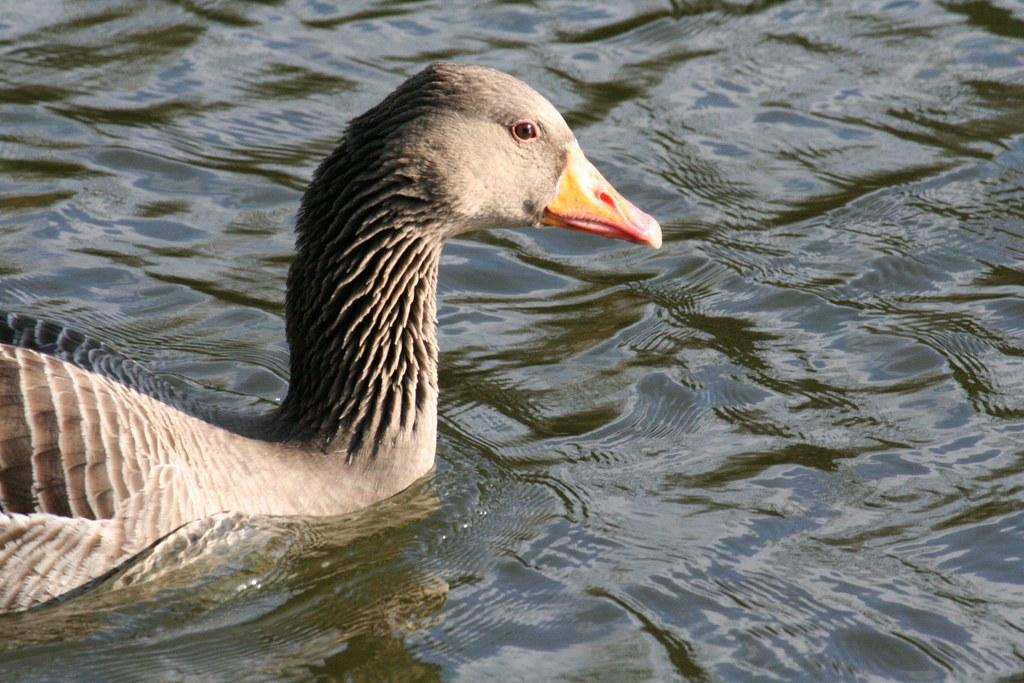What animal is present in the image? There is a duck in the image. Where is the duck located? The duck is in the water. How does the duck pull the neck in the image? The duck does not pull its neck in the image; it is simply swimming in the water. 